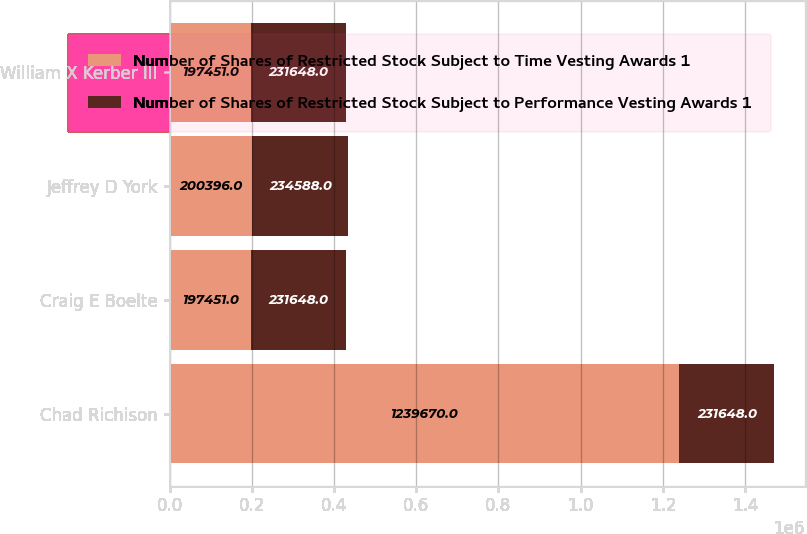Convert chart to OTSL. <chart><loc_0><loc_0><loc_500><loc_500><stacked_bar_chart><ecel><fcel>Chad Richison<fcel>Craig E Boelte<fcel>Jeffrey D York<fcel>William X Kerber III<nl><fcel>Number of Shares of Restricted Stock Subject to Time Vesting Awards 1<fcel>1.23967e+06<fcel>197451<fcel>200396<fcel>197451<nl><fcel>Number of Shares of Restricted Stock Subject to Performance Vesting Awards 1<fcel>231648<fcel>231648<fcel>234588<fcel>231648<nl></chart> 